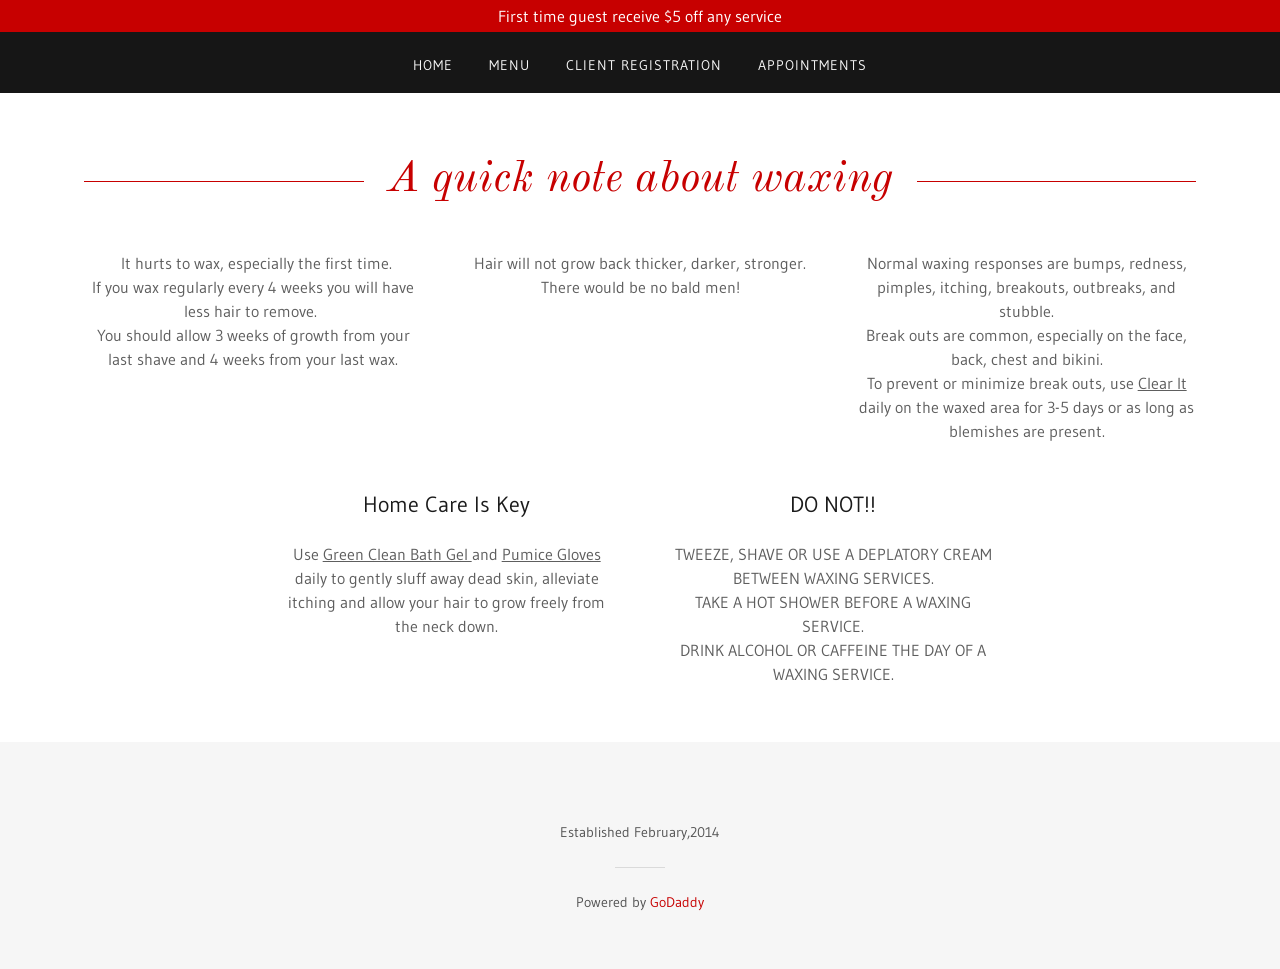Could you guide me through the process of developing this website with HTML? To develop a website like the one shown in the image using HTML, you'd start by crafting a structured layout with HTML elements to segment the website into logical sections, such as the header, main content, and footer. Use the <header>, <main>, and <footer> tags to define these areas. Inside, use <div> tags for internal division and layout management. For content headings, use <h1> to <h6> tags where necessary, especially for the 'A quick note about waxing' which can be marked up as an <h1> for emphasis and SEO benefits. Utilize <p> tags to wrap the text and <a> tags for the links in the navigation bar. Style the site using external CSS to handle visuals like fonts, colors, and layout properties to mimic the elegant, clean aesthetics as seen in the image. Lastly, apply responsive design practices using CSS media queries to ensure the website looks good on both mobile and desktop views. Including clear, informative meta tags within your head tag will also improve the website's SEO performance. 